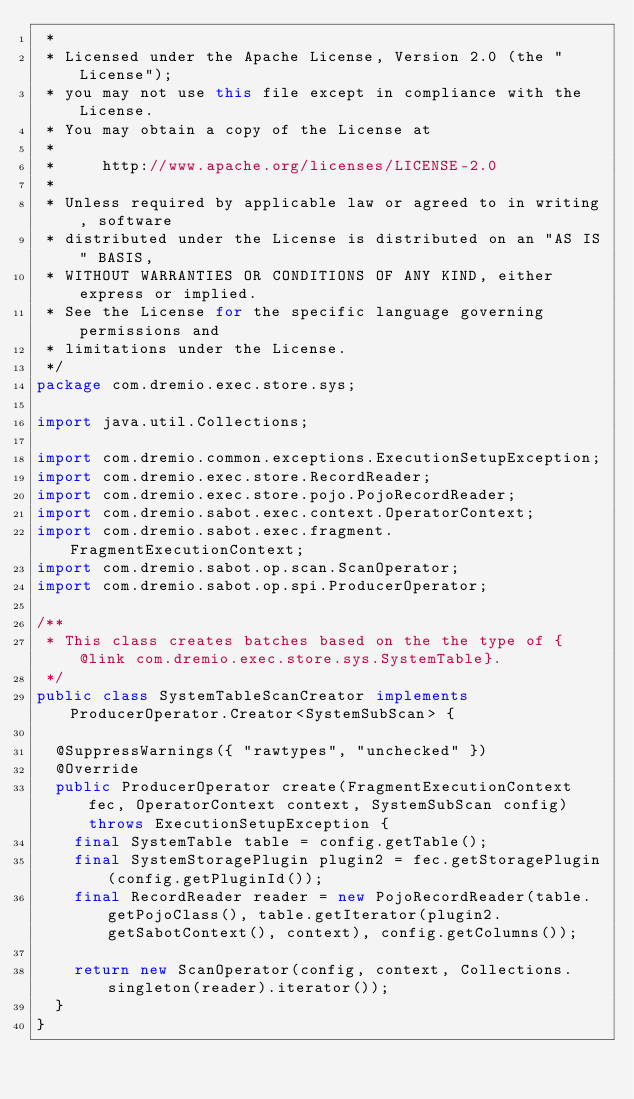Convert code to text. <code><loc_0><loc_0><loc_500><loc_500><_Java_> *
 * Licensed under the Apache License, Version 2.0 (the "License");
 * you may not use this file except in compliance with the License.
 * You may obtain a copy of the License at
 *
 *     http://www.apache.org/licenses/LICENSE-2.0
 *
 * Unless required by applicable law or agreed to in writing, software
 * distributed under the License is distributed on an "AS IS" BASIS,
 * WITHOUT WARRANTIES OR CONDITIONS OF ANY KIND, either express or implied.
 * See the License for the specific language governing permissions and
 * limitations under the License.
 */
package com.dremio.exec.store.sys;

import java.util.Collections;

import com.dremio.common.exceptions.ExecutionSetupException;
import com.dremio.exec.store.RecordReader;
import com.dremio.exec.store.pojo.PojoRecordReader;
import com.dremio.sabot.exec.context.OperatorContext;
import com.dremio.sabot.exec.fragment.FragmentExecutionContext;
import com.dremio.sabot.op.scan.ScanOperator;
import com.dremio.sabot.op.spi.ProducerOperator;

/**
 * This class creates batches based on the the type of {@link com.dremio.exec.store.sys.SystemTable}.
 */
public class SystemTableScanCreator implements ProducerOperator.Creator<SystemSubScan> {

  @SuppressWarnings({ "rawtypes", "unchecked" })
  @Override
  public ProducerOperator create(FragmentExecutionContext fec, OperatorContext context, SystemSubScan config) throws ExecutionSetupException {
    final SystemTable table = config.getTable();
    final SystemStoragePlugin plugin2 = fec.getStoragePlugin(config.getPluginId());
    final RecordReader reader = new PojoRecordReader(table.getPojoClass(), table.getIterator(plugin2.getSabotContext(), context), config.getColumns());

    return new ScanOperator(config, context, Collections.singleton(reader).iterator());
  }
}
</code> 